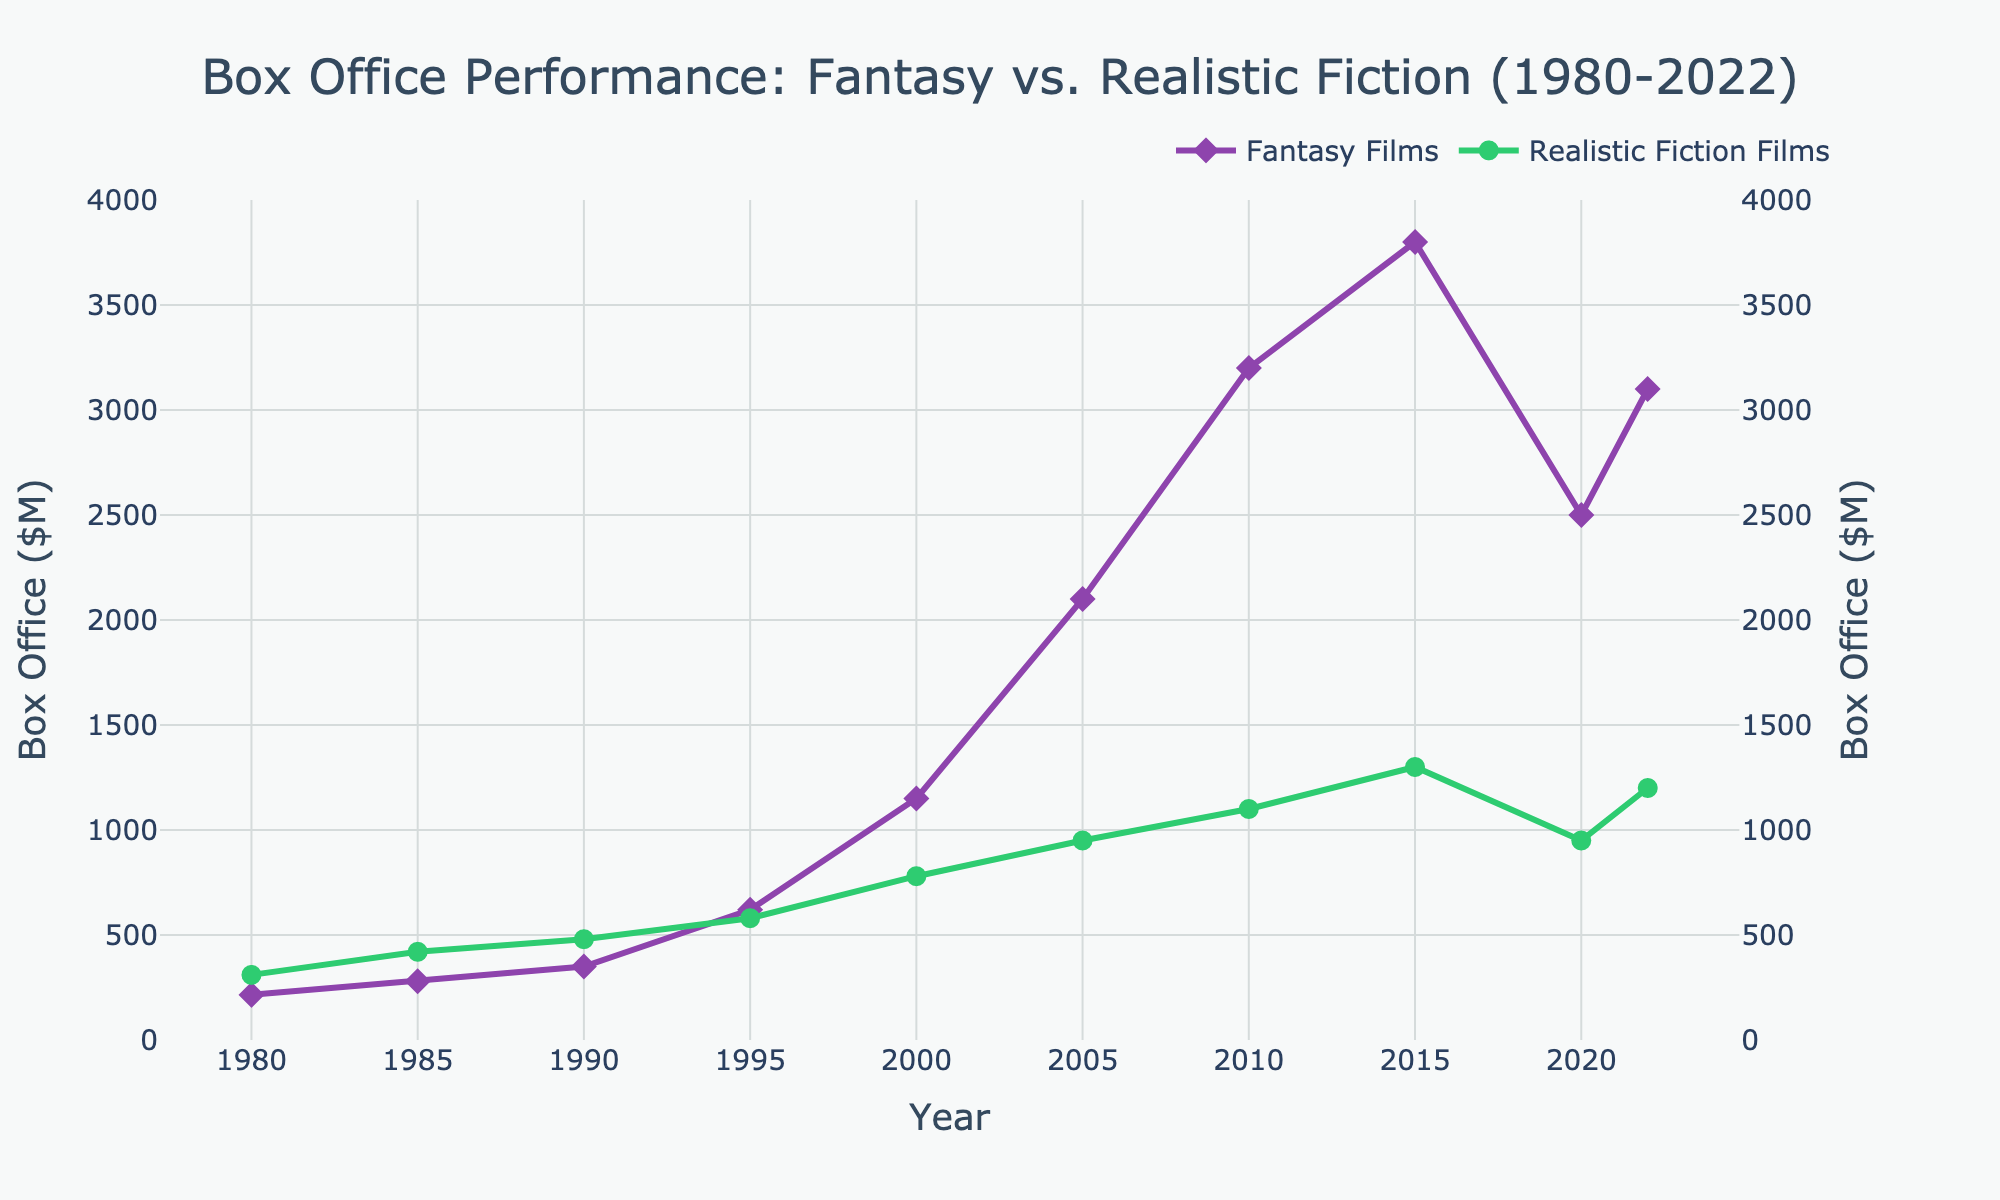Which year had the highest box office performance for Fantasy Films? From the chart, the line representing the box office for Fantasy Films reaches its highest point in 2015.
Answer: 2015 How much more did Fantasy Films make in 2005 compared to Realistic Fiction Films in the same year? In 2005, Fantasy Films made $2100M and Realistic Fiction Films made $950M. The difference is $2100M - $950M.
Answer: $1150M During which years was the box office performance of Fantasy Films less than that of Realistic Fiction Films? By observing the two lines, Fantasy Films had lower box office revenue in 1980, 1985, 1990, and 1995.
Answer: 1980, 1985, 1990, 1995 What is the average box office performance of Fantasy Films between 2000 and 2022? Adding up the box office numbers for years 2000, 2005, 2010, 2015, 2020, and 2022: ($1150M + $2100M + $3200M + $3800M + $2500M + $3100M) = $15850M. Then divide by the number of years (6).
Answer: $2641.67M What was the percentage decline in the box office for Fantasy Films from 2015 to 2020? Fantasy Films made $3800M in 2015 and $2500M in 2020. The decline amount is $3800M - $2500M = $1300M. The percentage decline is ($1300M / $3800M) * 100.
Answer: 34.2% How did the box office performance of Realistic Fiction Films change from 1980 to 2022? In 1980, Realistic Fiction Films made $310M and in 2022, they made $1200M. The change is $1200M - $310M, which shows an increase of $890M.
Answer: Increased by $890M In which years did both genres have their box office values increase compared to the previous period? Looking at both lines, both genres increased in 1985, 1990, 1995, 2000, 2005, 2010, 2015, and 2022.
Answer: 1985, 1990, 1995, 2000, 2005, 2010, 2015, 2022 By how much did the box office for Realistic Fiction Films increase from 2010 to 2015? Realistic Fiction Films made $1100M in 2010 and $1300M in 2015. The increase is $1300M - $1100M.
Answer: $200M Which genre had more box office performance growth from 2000 to 2005? In 2000, Fantasy Films made $1150M and in 2005 they made $2100M, a growth of $950M. Realistic Fiction Films went from $780M in 2000 to $950M in 2005, a growth of $170M. Comparing the two, Fantasy Films had more growth.
Answer: Fantasy Films In which year was the difference between the box office performance of Fantasy and Realistic Fiction Films the largest? Observing the chart, the biggest gap appears in 2015 where Fantasy Films made $3800M and Realistic Fiction Films made $1300M. The difference is $3800M - $1300M.
Answer: 2015 